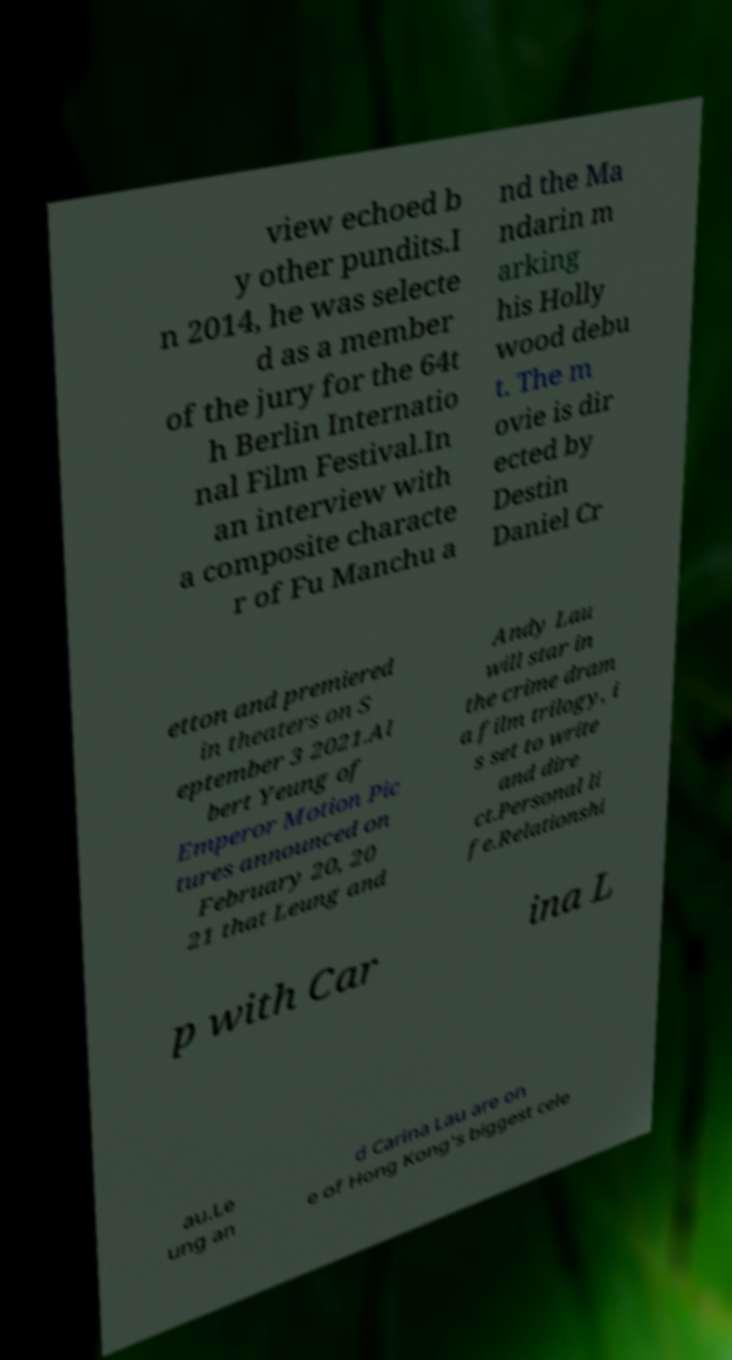Could you assist in decoding the text presented in this image and type it out clearly? view echoed b y other pundits.I n 2014, he was selecte d as a member of the jury for the 64t h Berlin Internatio nal Film Festival.In an interview with a composite characte r of Fu Manchu a nd the Ma ndarin m arking his Holly wood debu t. The m ovie is dir ected by Destin Daniel Cr etton and premiered in theaters on S eptember 3 2021.Al bert Yeung of Emperor Motion Pic tures announced on February 20, 20 21 that Leung and Andy Lau will star in the crime dram a film trilogy, i s set to write and dire ct.Personal li fe.Relationshi p with Car ina L au.Le ung an d Carina Lau are on e of Hong Kong's biggest cele 